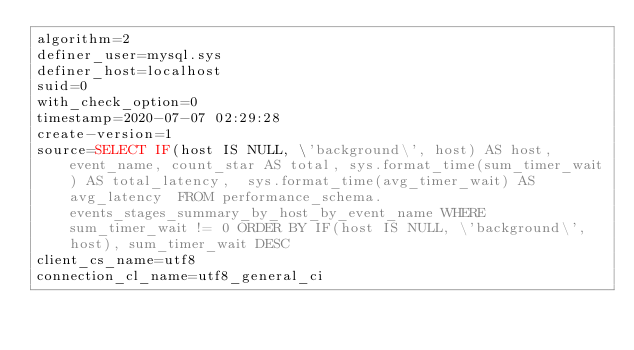<code> <loc_0><loc_0><loc_500><loc_500><_VisualBasic_>algorithm=2
definer_user=mysql.sys
definer_host=localhost
suid=0
with_check_option=0
timestamp=2020-07-07 02:29:28
create-version=1
source=SELECT IF(host IS NULL, \'background\', host) AS host, event_name, count_star AS total, sys.format_time(sum_timer_wait) AS total_latency,  sys.format_time(avg_timer_wait) AS avg_latency  FROM performance_schema.events_stages_summary_by_host_by_event_name WHERE sum_timer_wait != 0 ORDER BY IF(host IS NULL, \'background\', host), sum_timer_wait DESC
client_cs_name=utf8
connection_cl_name=utf8_general_ci</code> 